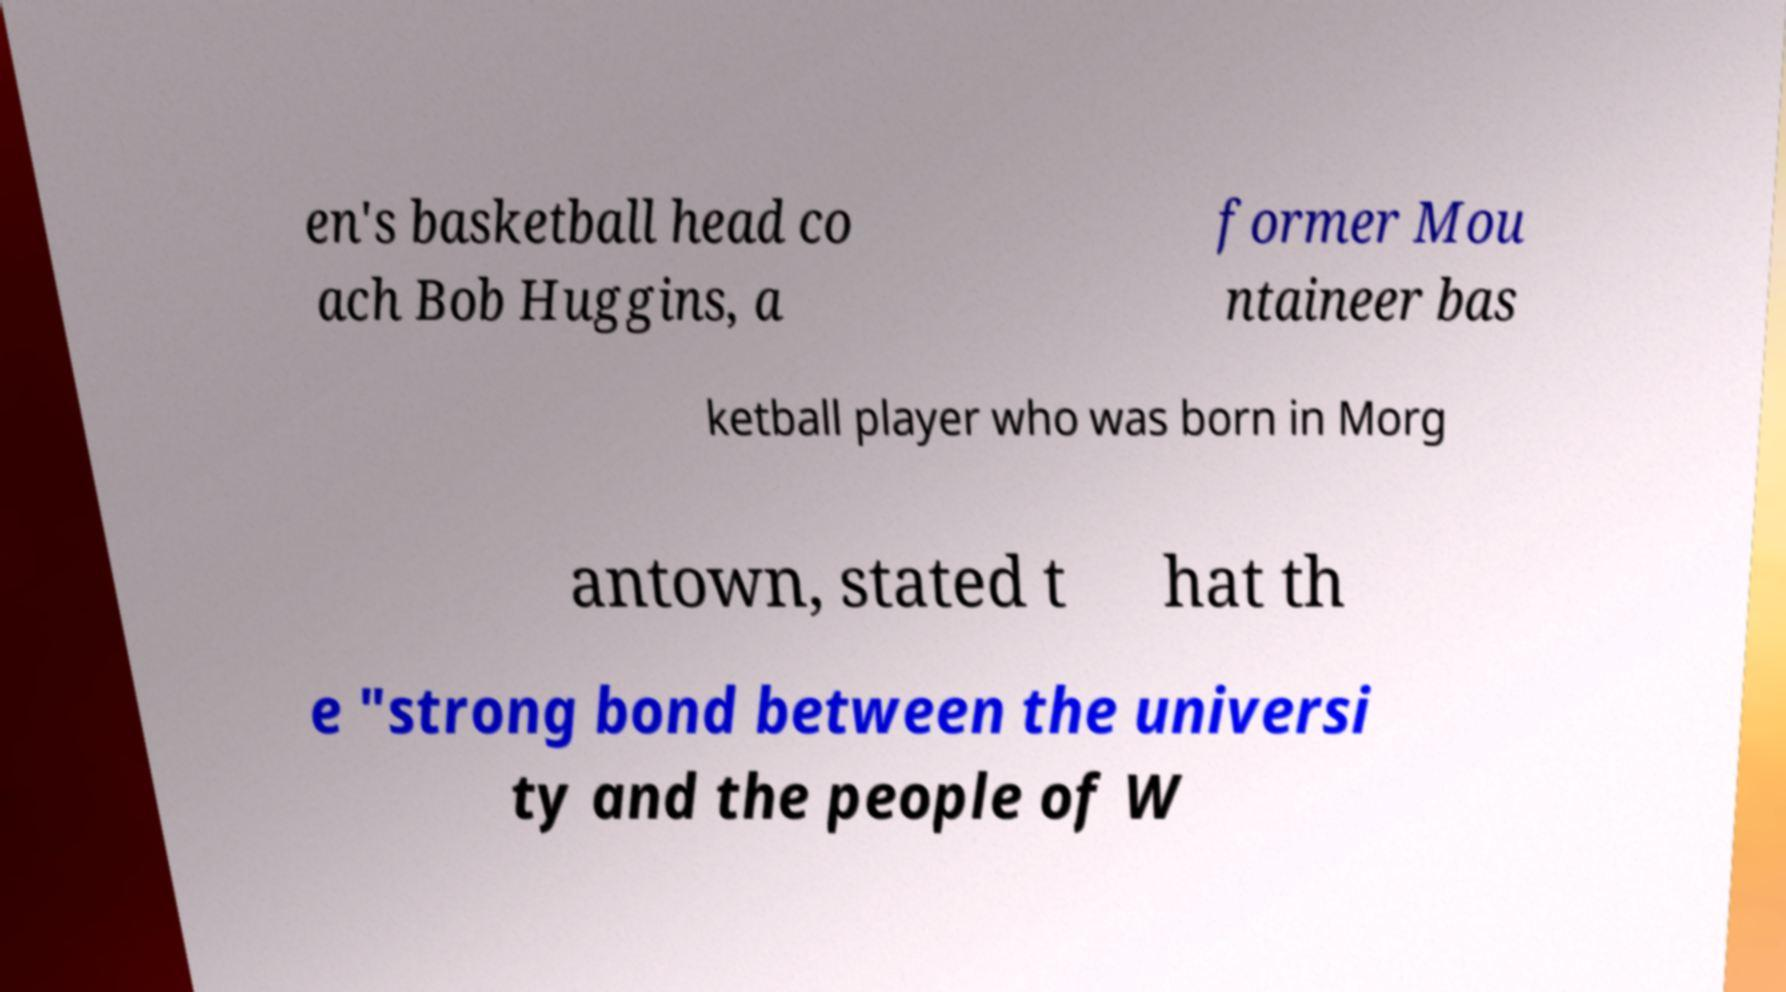Can you read and provide the text displayed in the image?This photo seems to have some interesting text. Can you extract and type it out for me? en's basketball head co ach Bob Huggins, a former Mou ntaineer bas ketball player who was born in Morg antown, stated t hat th e "strong bond between the universi ty and the people of W 